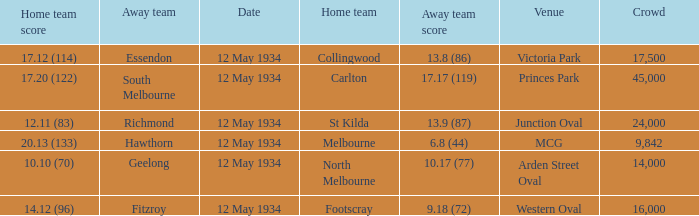What place had an Away team get a score of 10.17 (77)? Arden Street Oval. 